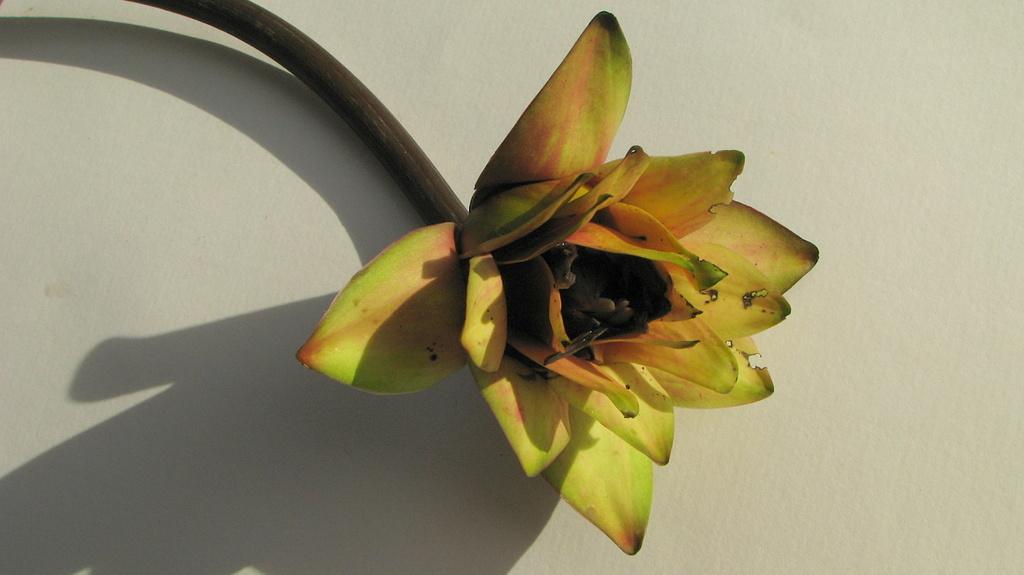Can you describe this image briefly? In this image, we can see a flower on the white background. 